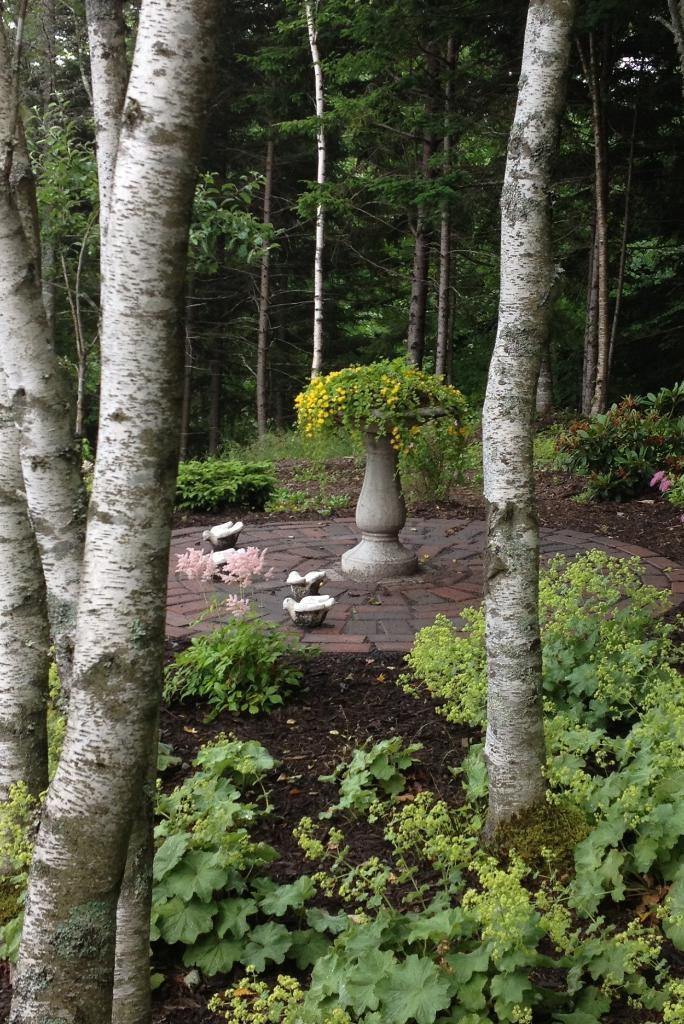What type of living organisms can be seen on the ground in the image? There are plants on the ground in the image. What object is present in the image that might be used for holding plants? There is a pot in the image. What type of animals can be seen in the image? Birds are visible in the image. What type of vegetation can be seen in the background of the image? There are trees in the background of the image. Can you tell me how many planes are flying over the trees in the image? There are no planes visible in the image; it only features plants, a pot, birds, and trees. What type of fruit is being celebrated in the image? There is no fruit or celebration mentioned in the image; it only features plants, a pot, birds, and trees. 